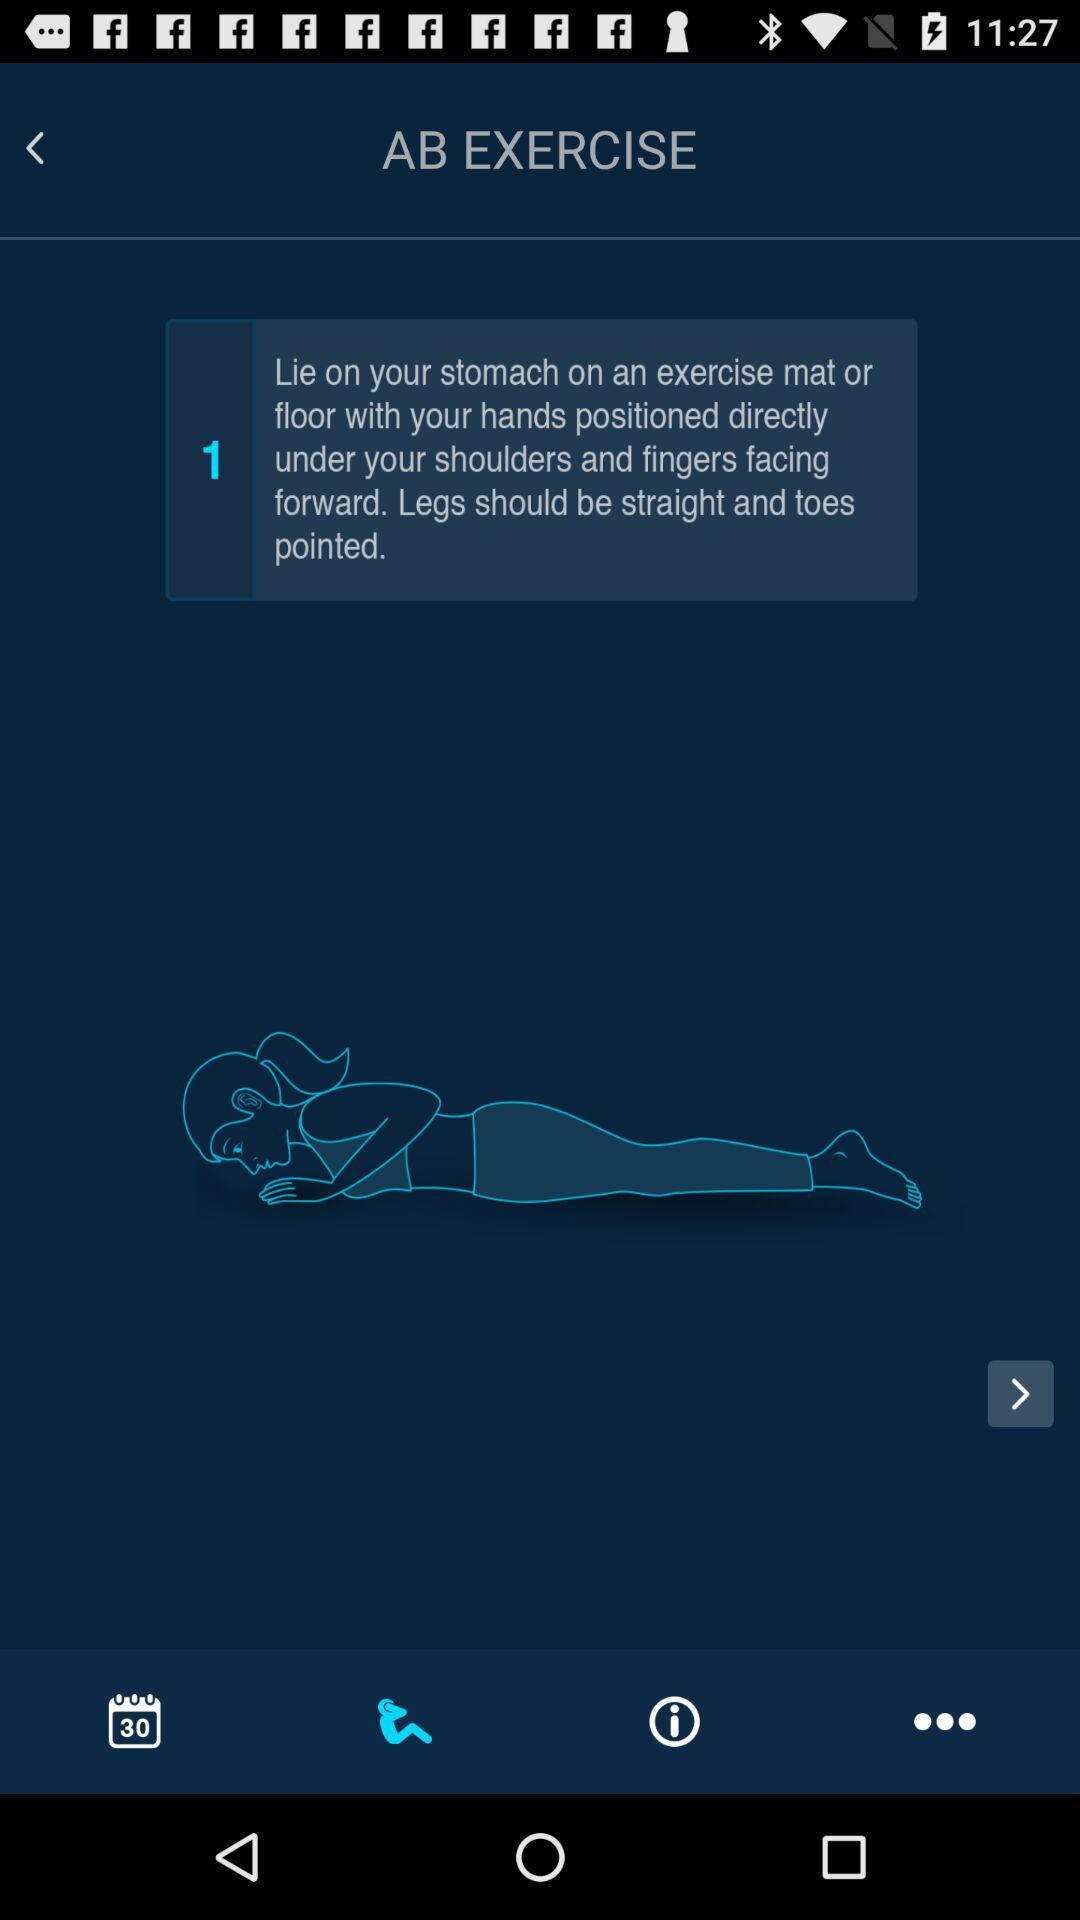How many steps are there in the exercise?
Answer the question using a single word or phrase. 1 